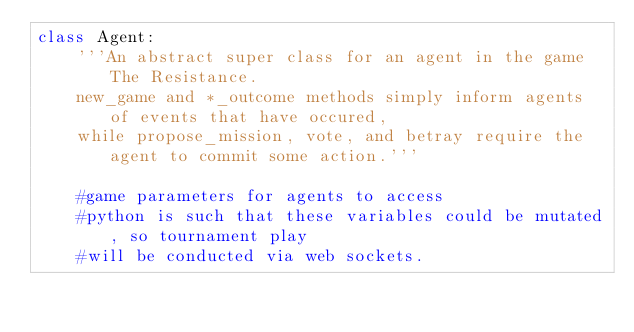Convert code to text. <code><loc_0><loc_0><loc_500><loc_500><_Python_>class Agent:
    '''An abstract super class for an agent in the game The Resistance.
    new_game and *_outcome methods simply inform agents of events that have occured,
    while propose_mission, vote, and betray require the agent to commit some action.'''

    #game parameters for agents to access
    #python is such that these variables could be mutated, so tournament play
    #will be conducted via web sockets.</code> 